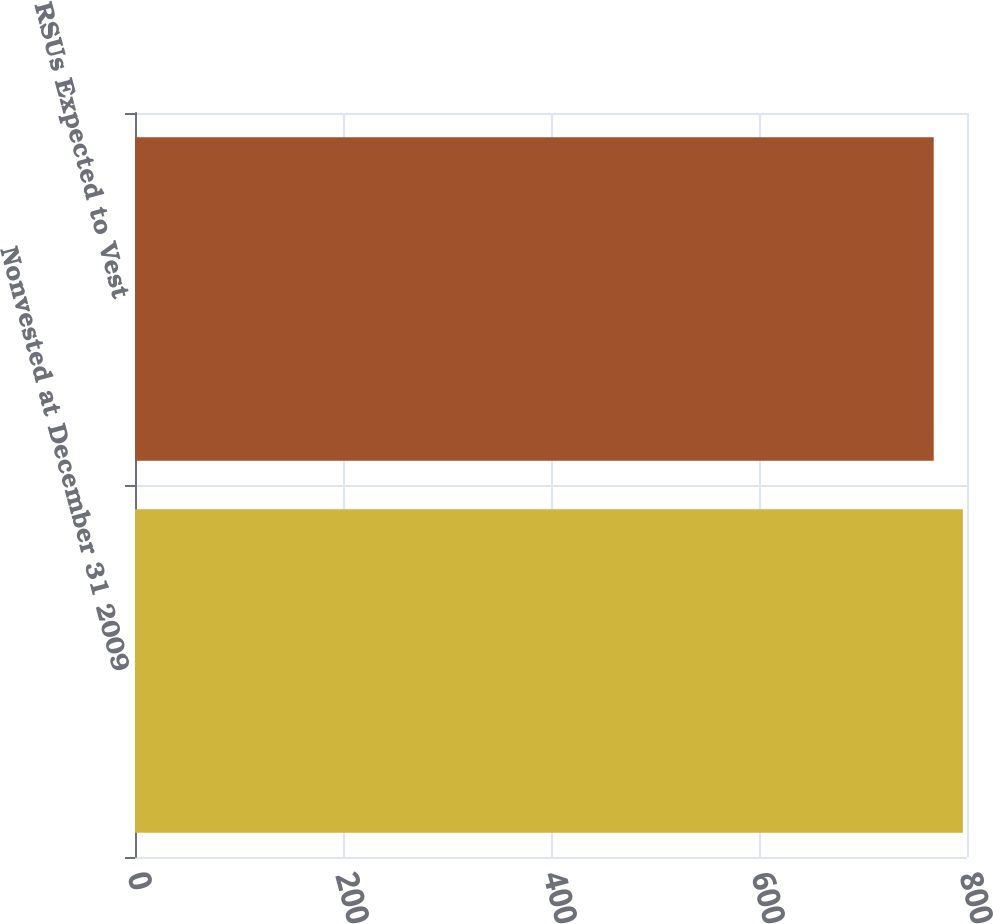<chart> <loc_0><loc_0><loc_500><loc_500><bar_chart><fcel>Nonvested at December 31 2009<fcel>RSUs Expected to Vest<nl><fcel>796<fcel>768<nl></chart> 